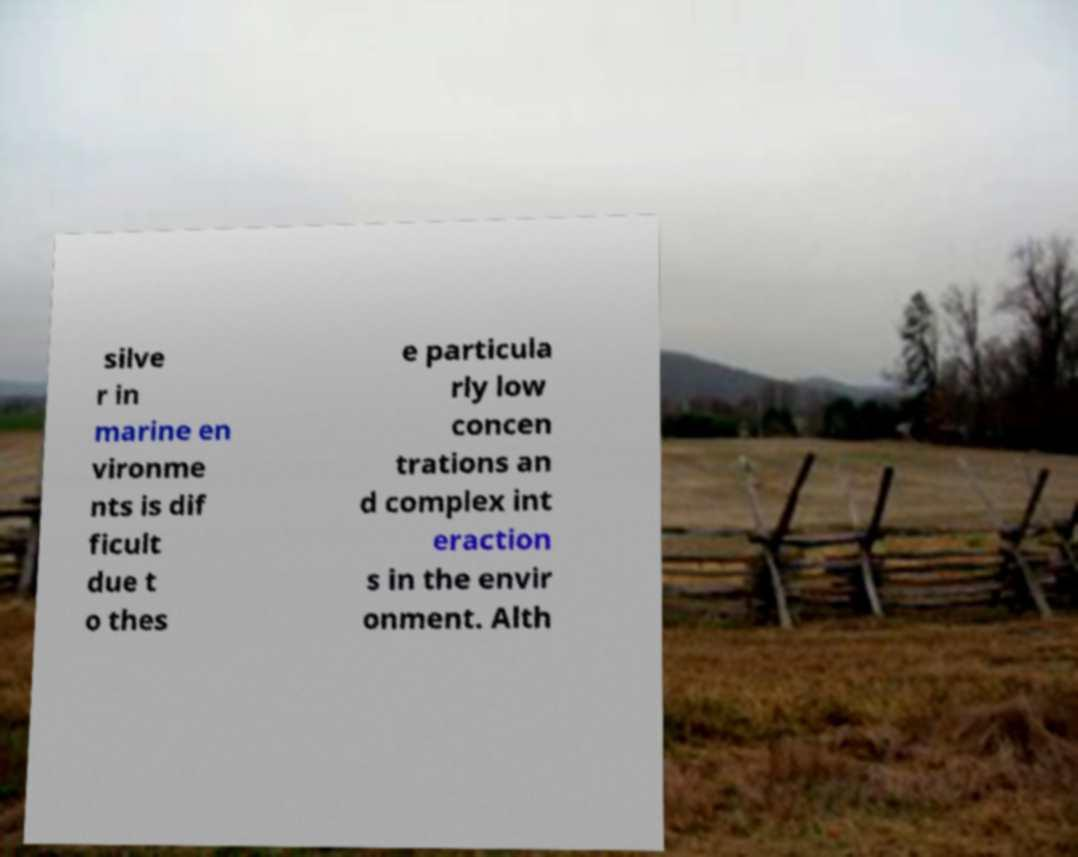There's text embedded in this image that I need extracted. Can you transcribe it verbatim? silve r in marine en vironme nts is dif ficult due t o thes e particula rly low concen trations an d complex int eraction s in the envir onment. Alth 